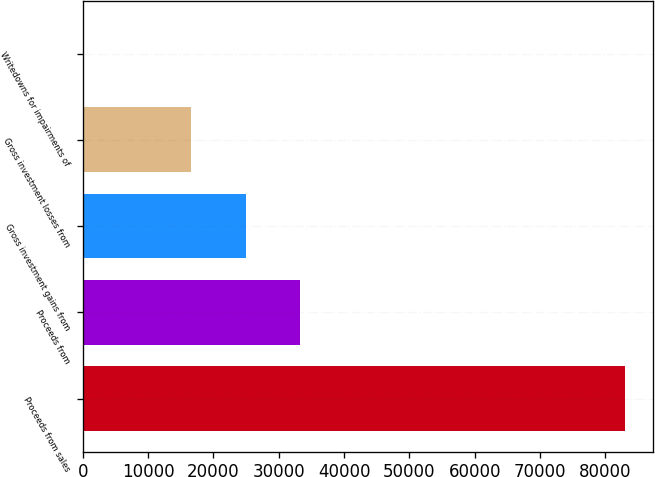<chart> <loc_0><loc_0><loc_500><loc_500><bar_chart><fcel>Proceeds from sales<fcel>Proceeds from<fcel>Gross investment gains from<fcel>Gross investment losses from<fcel>Writedowns for impairments of<nl><fcel>83075<fcel>33248.6<fcel>24944.2<fcel>16639.8<fcel>31<nl></chart> 